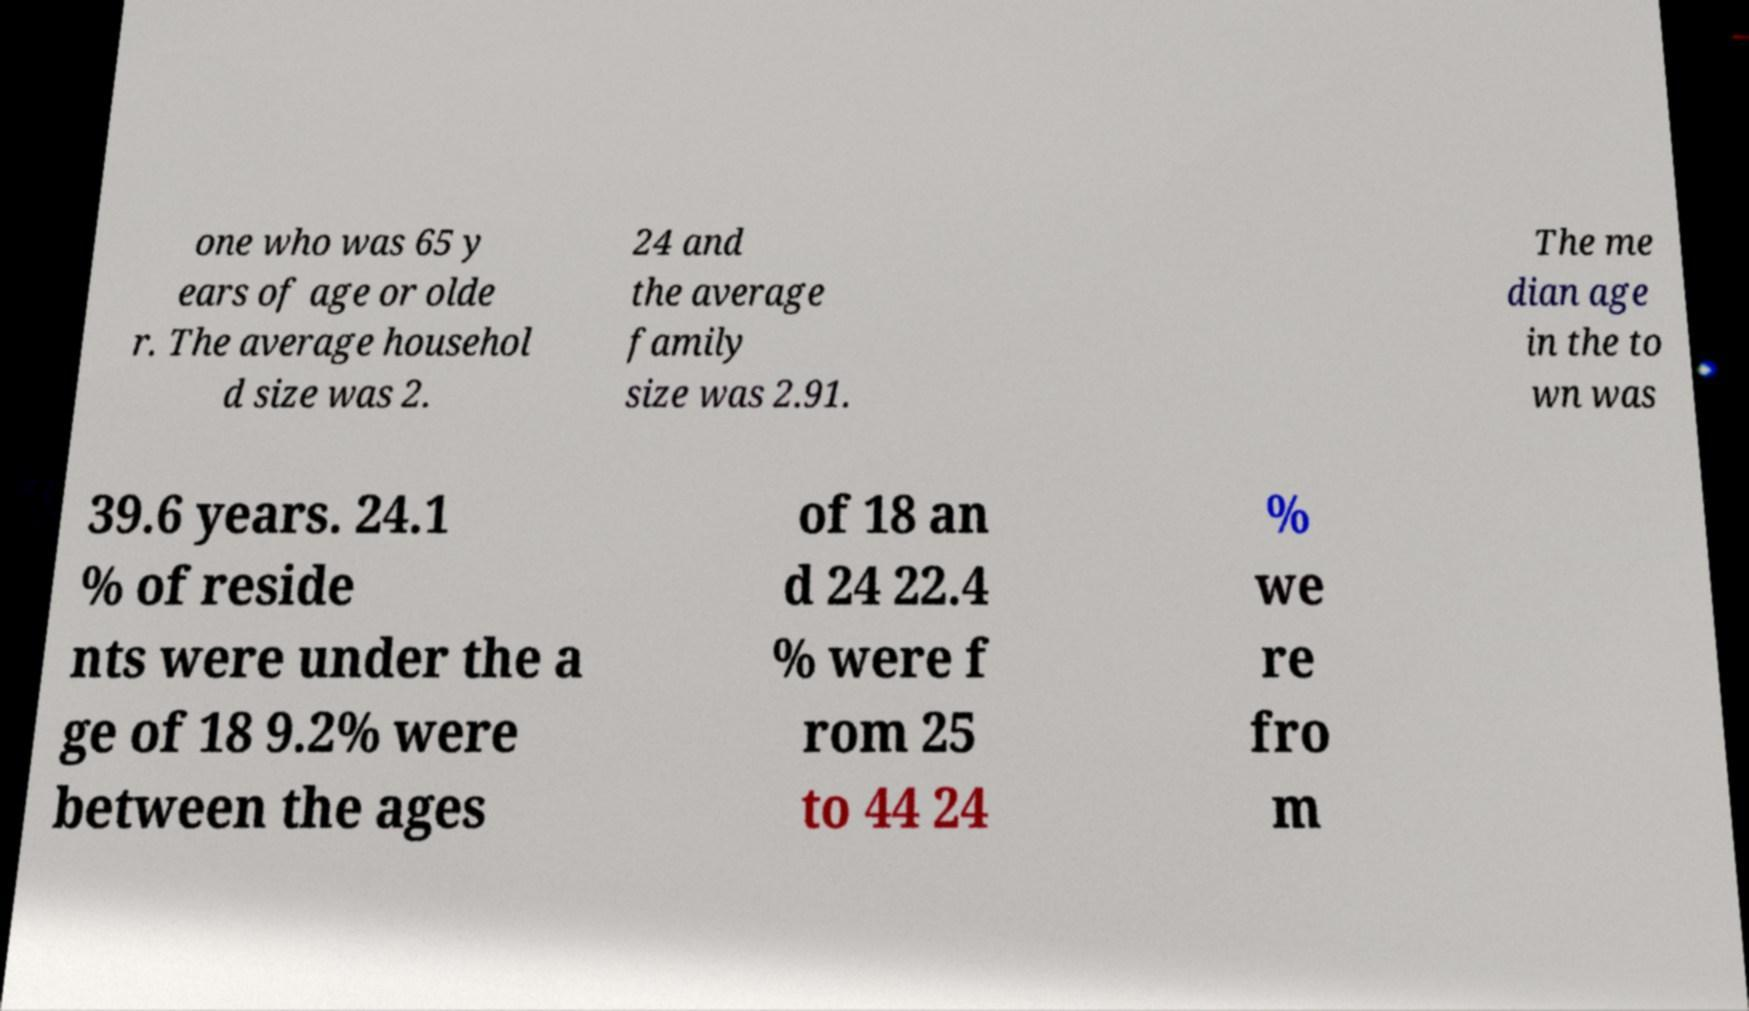Please identify and transcribe the text found in this image. one who was 65 y ears of age or olde r. The average househol d size was 2. 24 and the average family size was 2.91. The me dian age in the to wn was 39.6 years. 24.1 % of reside nts were under the a ge of 18 9.2% were between the ages of 18 an d 24 22.4 % were f rom 25 to 44 24 % we re fro m 